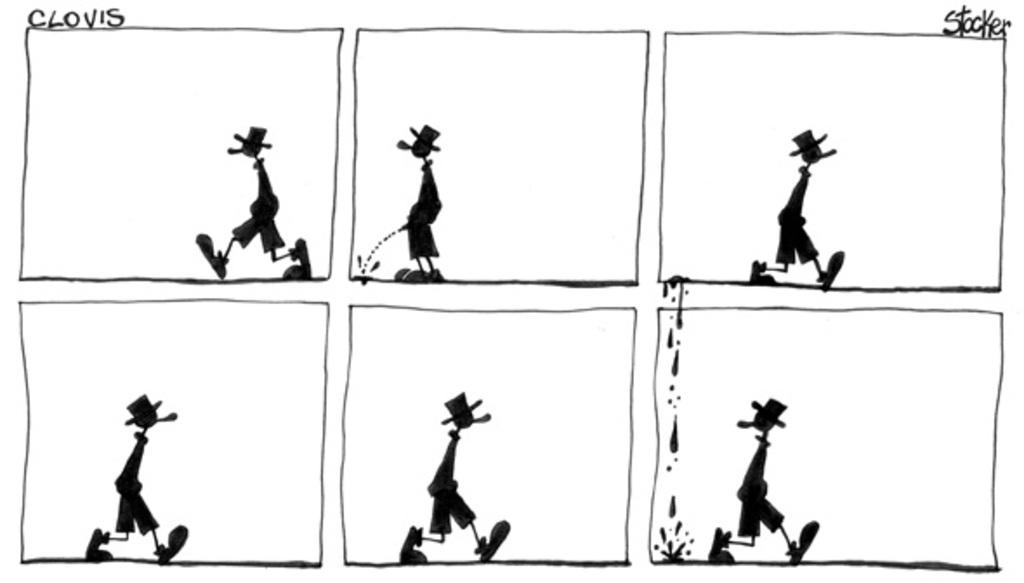What type of image is shown in the picture? The image is a collage of pictures. What style is the collage in? The collage is a cartoon image. Can you describe the person in the image? There is a person standing in the image. What color scheme is used in the image? The image is in black and white color. What type of linen is used to create the background of the image? There is no linen present in the image, as it is a collage of pictures in a cartoon style. Can you tell me how many guitars the person in the image is holding? There is no guitar visible in the image; the person is not holding any musical instruments. 